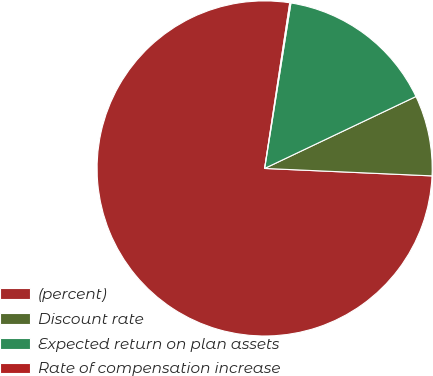Convert chart to OTSL. <chart><loc_0><loc_0><loc_500><loc_500><pie_chart><fcel>(percent)<fcel>Discount rate<fcel>Expected return on plan assets<fcel>Rate of compensation increase<nl><fcel>76.69%<fcel>7.77%<fcel>15.43%<fcel>0.11%<nl></chart> 